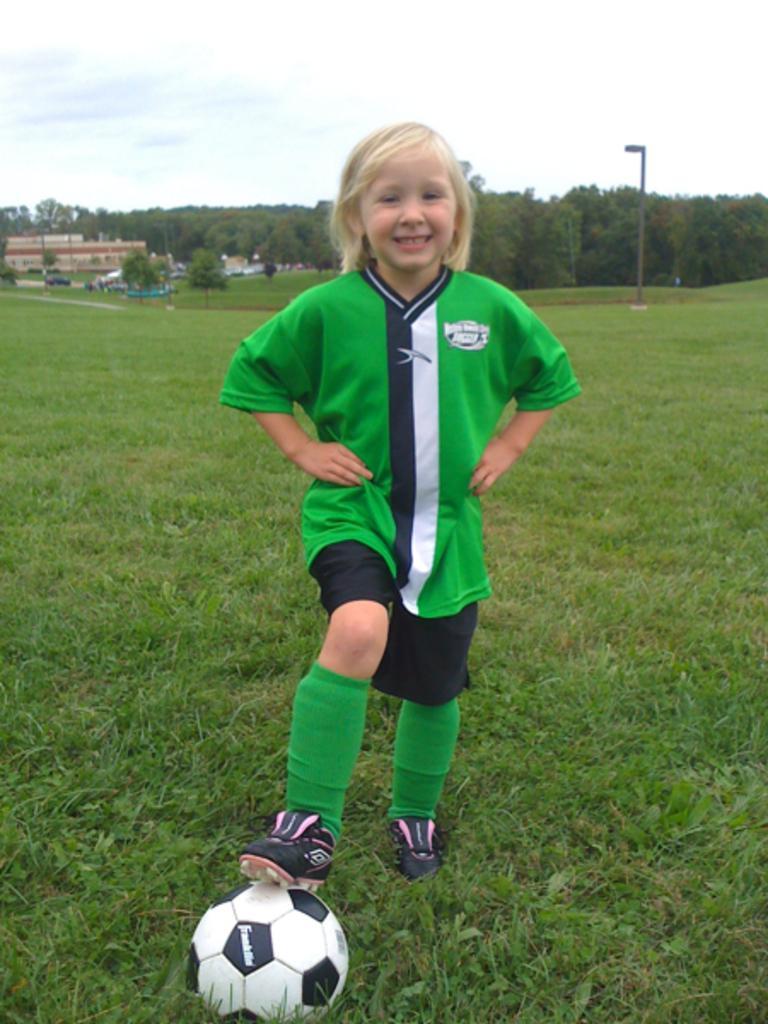Describe this image in one or two sentences. In this picture we can see a small girl wearing green color t-shirt and black shorts standing with the football, smiling and giving a pose into the camera. Behind there are some trees and houses. 